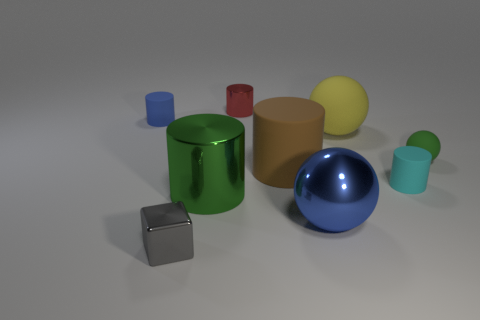Does the tiny ball have the same color as the big metal cylinder?
Your response must be concise. Yes. How many small blue rubber objects are behind the small metallic thing on the left side of the large green thing?
Your answer should be compact. 1. What is the shape of the blue object that is to the left of the tiny metallic cube?
Your response must be concise. Cylinder. There is a big cylinder that is to the left of the small cylinder that is behind the rubber thing that is behind the yellow matte thing; what is it made of?
Offer a very short reply. Metal. What number of other objects are there of the same size as the blue cylinder?
Give a very brief answer. 4. What material is the green object that is the same shape as the tiny red object?
Offer a terse response. Metal. What color is the metal ball?
Provide a succinct answer. Blue. What is the color of the matte thing that is to the left of the green object that is left of the metallic sphere?
Make the answer very short. Blue. There is a small rubber sphere; is its color the same as the metallic cylinder that is in front of the cyan cylinder?
Your answer should be very brief. Yes. How many tiny green spheres are in front of the thing behind the small matte cylinder behind the green matte thing?
Provide a succinct answer. 1. 